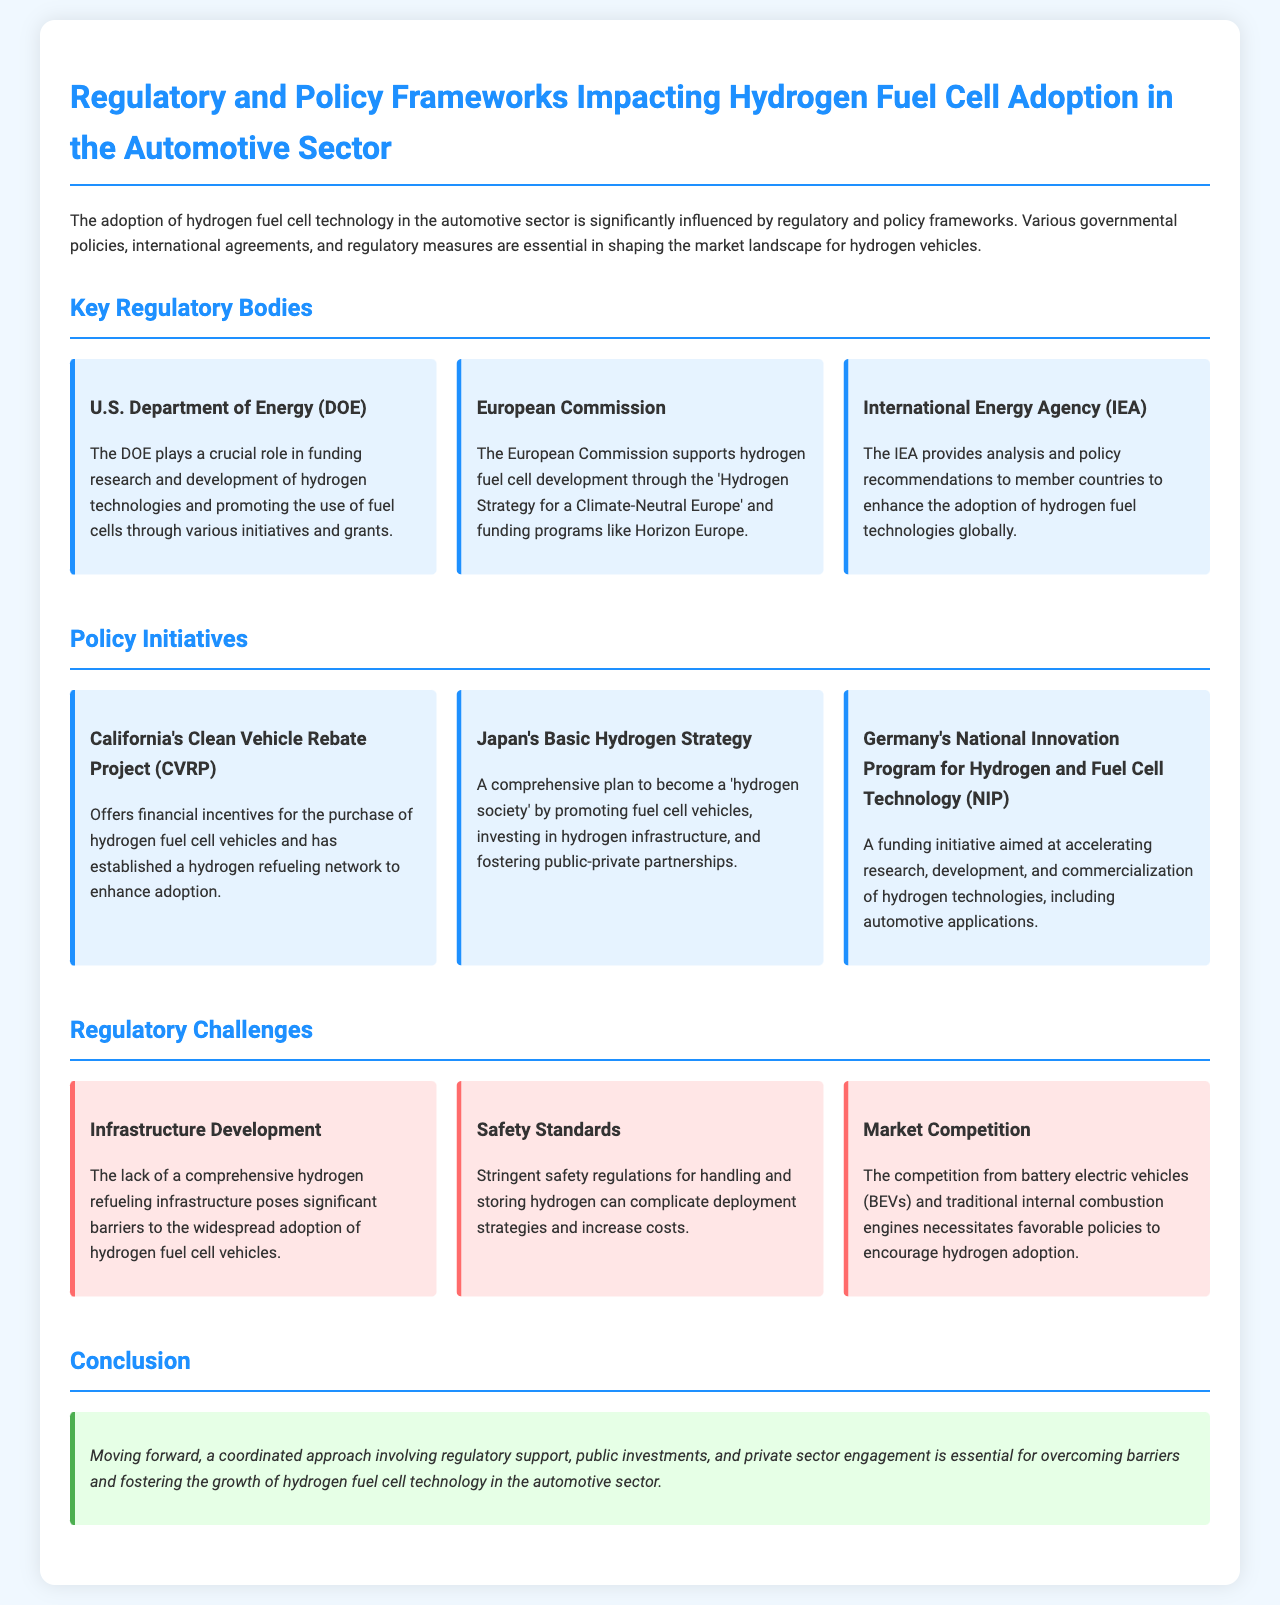What is the role of the U.S. Department of Energy? The U.S. Department of Energy plays a crucial role in funding research and development of hydrogen technologies and promoting the use of fuel cells through various initiatives and grants.
Answer: funding research and development What initiative does California offer for hydrogen vehicles? California's Clean Vehicle Rebate Project (CVRP) offers financial incentives for the purchase of hydrogen fuel cell vehicles.
Answer: Clean Vehicle Rebate Project What is a key challenge related to hydrogen fuel cell adoption? A significant barrier to widespread adoption of hydrogen fuel cell vehicles is the lack of a comprehensive hydrogen refueling infrastructure.
Answer: Infrastructure Development Which country has a Basic Hydrogen Strategy? Japan has a Basic Hydrogen Strategy as part of its plan to promote fuel cell vehicles and invest in hydrogen infrastructure.
Answer: Japan What funding program does the European Commission support? The European Commission supports the 'Hydrogen Strategy for a Climate-Neutral Europe' and funding programs like Horizon Europe.
Answer: Hydrogen Strategy for a Climate-Neutral Europe What is necessary for fostering the growth of hydrogen fuel cell technology? A coordinated approach involving regulatory support, public investments, and private sector engagement is essential.
Answer: coordinated approach What does the International Energy Agency provide? The International Energy Agency provides analysis and policy recommendations to member countries to enhance the adoption of hydrogen fuel technologies globally.
Answer: analysis and policy recommendations What does Germany's NIP aim to accelerate? Germany's National Innovation Program for Hydrogen and Fuel Cell Technology (NIP) aims at accelerating research, development, and commercialization of hydrogen technologies.
Answer: research, development, and commercialization 